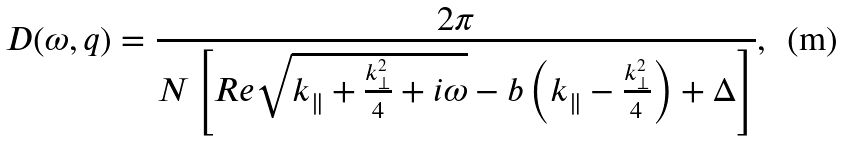Convert formula to latex. <formula><loc_0><loc_0><loc_500><loc_500>D ( \omega , { q } ) = \frac { 2 \pi } { N \left [ R e \sqrt { k _ { \| } + \frac { k _ { \perp } ^ { 2 } } { 4 } + i \omega } - b \left ( k _ { \| } - \frac { k _ { \perp } ^ { 2 } } { 4 } \right ) + \Delta \right ] } ,</formula> 